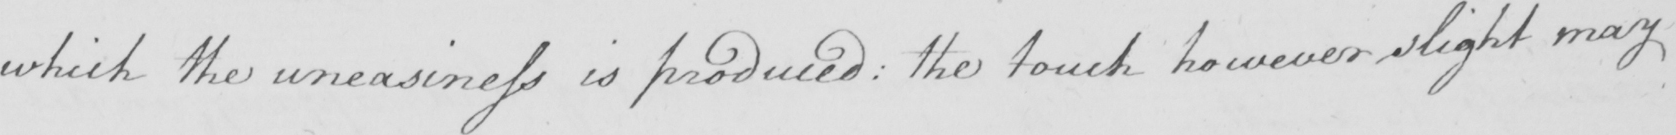Transcribe the text shown in this historical manuscript line. which the uneasiness is produced: the touch however slight may 